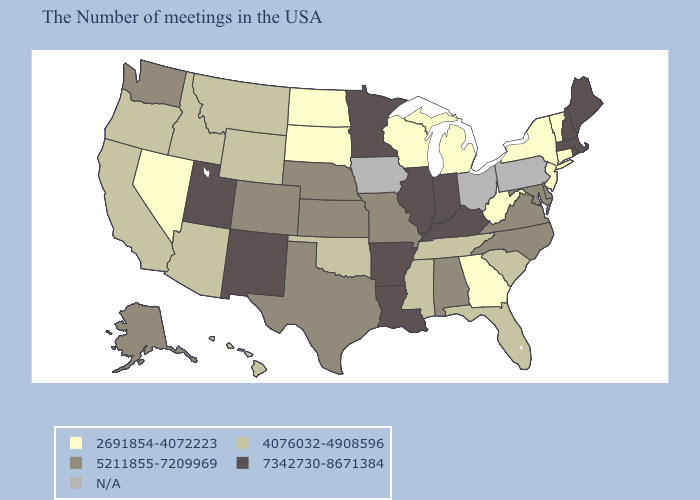Does Maine have the lowest value in the Northeast?
Quick response, please. No. Name the states that have a value in the range 4076032-4908596?
Keep it brief. South Carolina, Florida, Tennessee, Mississippi, Oklahoma, Wyoming, Montana, Arizona, Idaho, California, Oregon, Hawaii. Among the states that border Michigan , which have the highest value?
Quick response, please. Indiana. Does Alaska have the lowest value in the USA?
Keep it brief. No. What is the value of Indiana?
Keep it brief. 7342730-8671384. Name the states that have a value in the range N/A?
Be succinct. Pennsylvania, Ohio, Iowa. What is the value of West Virginia?
Keep it brief. 2691854-4072223. What is the lowest value in states that border Wyoming?
Answer briefly. 2691854-4072223. What is the lowest value in the South?
Short answer required. 2691854-4072223. Among the states that border South Dakota , does North Dakota have the lowest value?
Quick response, please. Yes. What is the lowest value in states that border Nebraska?
Keep it brief. 2691854-4072223. Does Rhode Island have the highest value in the USA?
Write a very short answer. Yes. 